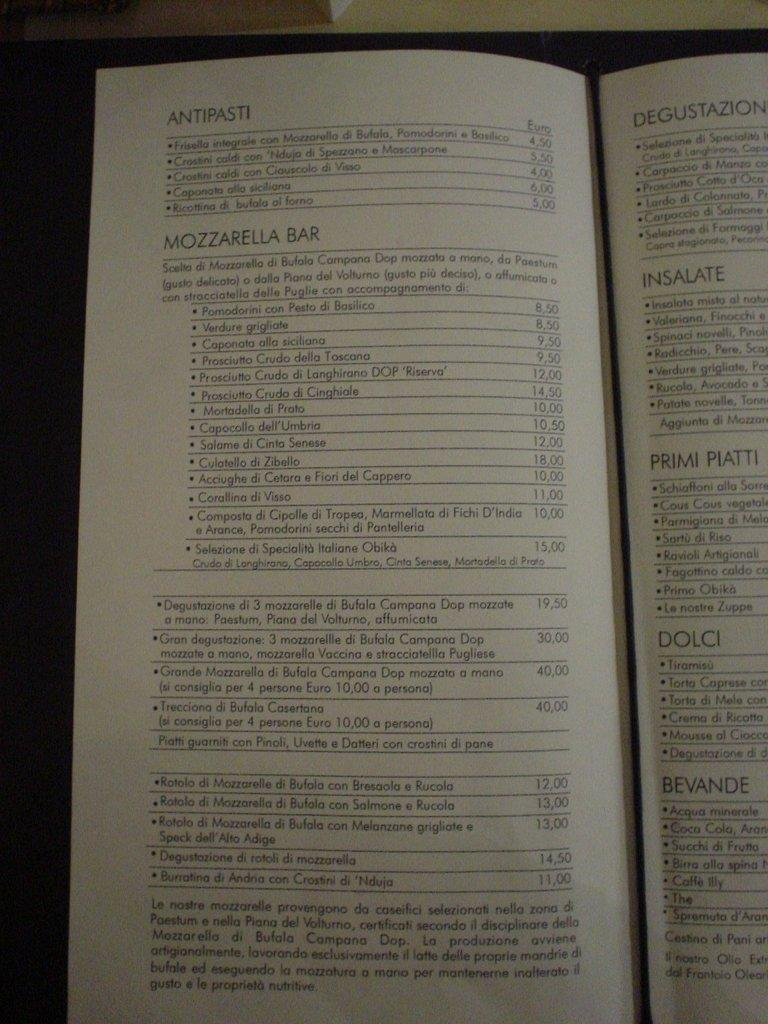<image>
Offer a succinct explanation of the picture presented. A menu at a restaurant that has many items such as a Mozzarella Bar. 